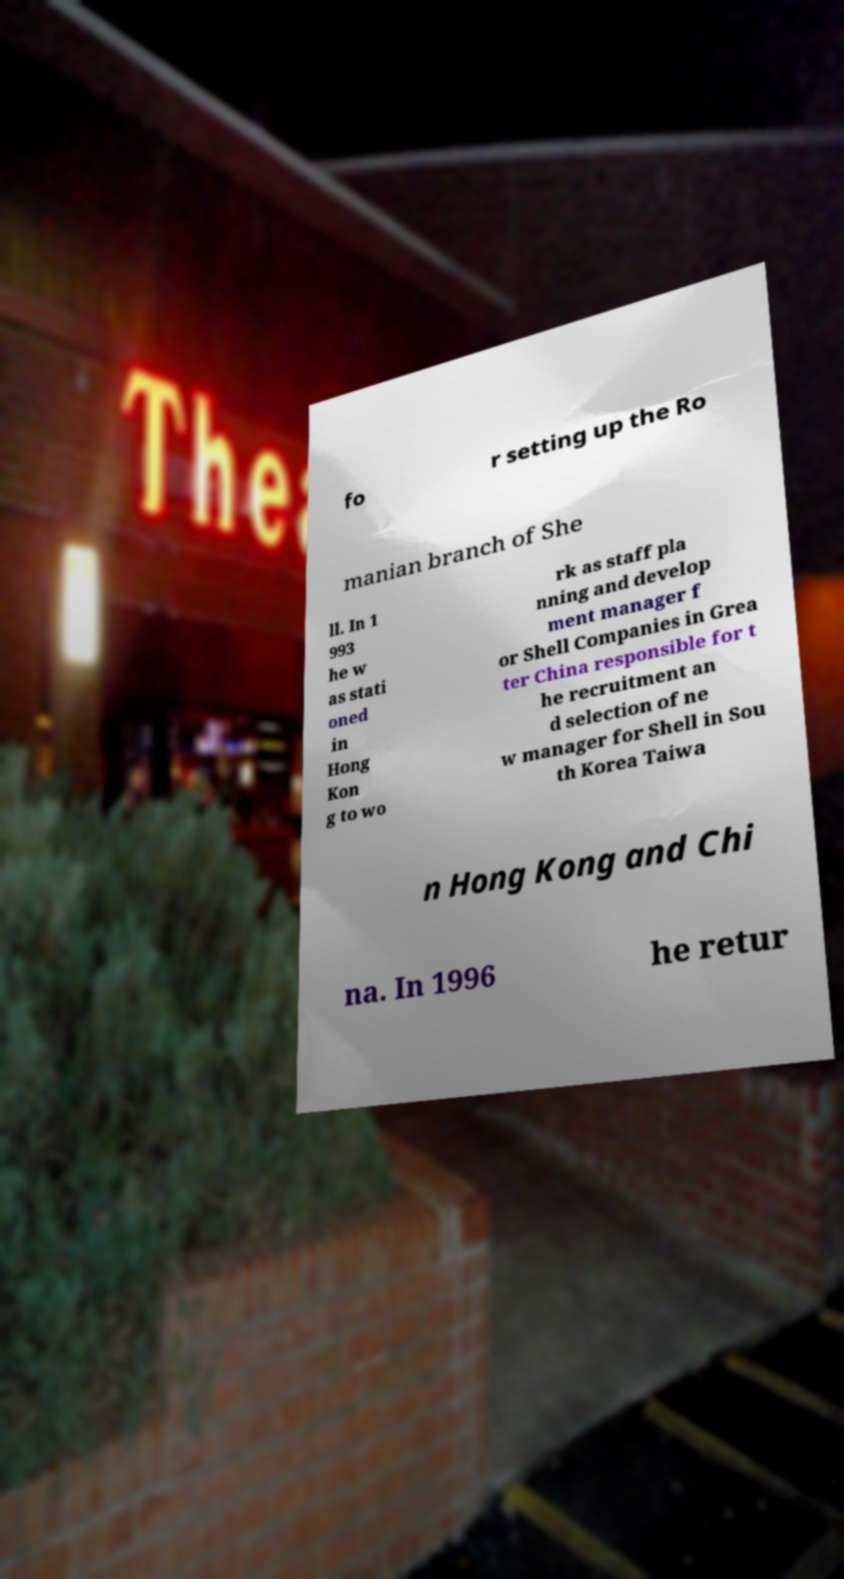Could you extract and type out the text from this image? fo r setting up the Ro manian branch of She ll. In 1 993 he w as stati oned in Hong Kon g to wo rk as staff pla nning and develop ment manager f or Shell Companies in Grea ter China responsible for t he recruitment an d selection of ne w manager for Shell in Sou th Korea Taiwa n Hong Kong and Chi na. In 1996 he retur 